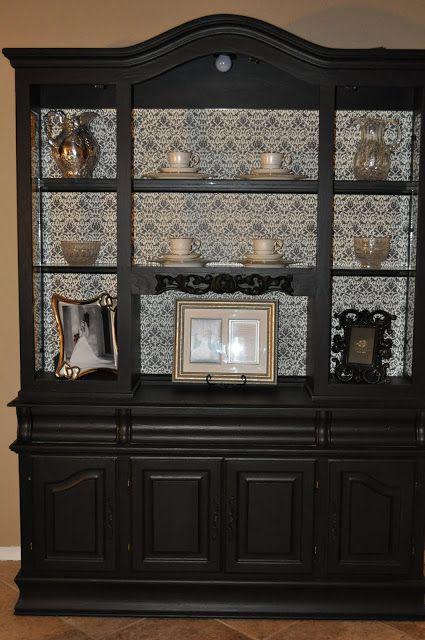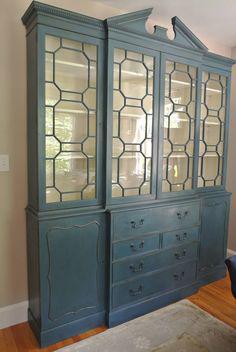The first image is the image on the left, the second image is the image on the right. For the images shown, is this caption "None of the cabinets are empty." true? Answer yes or no. No. 